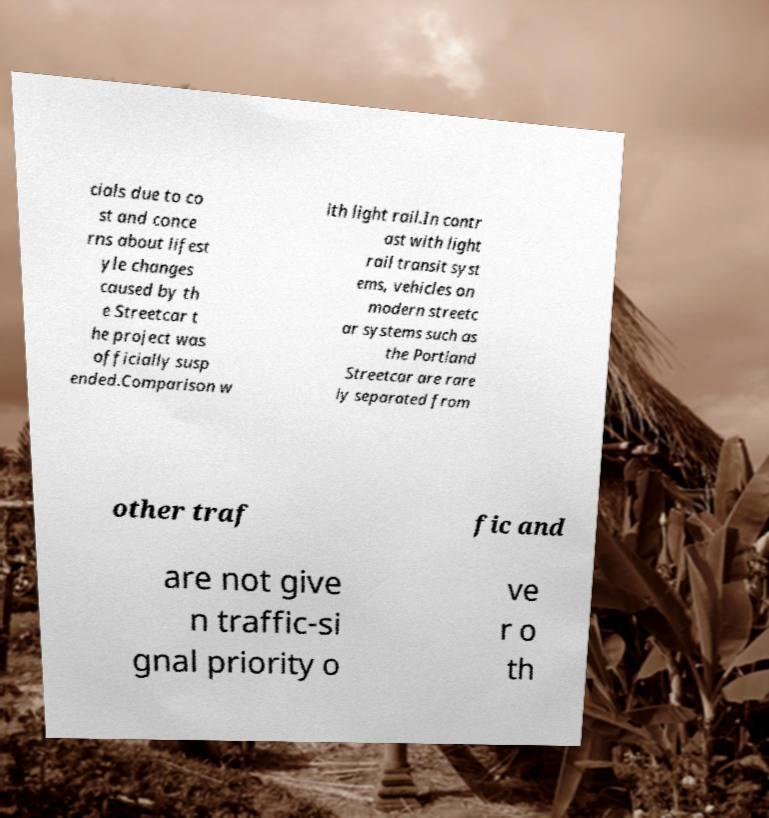Can you read and provide the text displayed in the image?This photo seems to have some interesting text. Can you extract and type it out for me? cials due to co st and conce rns about lifest yle changes caused by th e Streetcar t he project was officially susp ended.Comparison w ith light rail.In contr ast with light rail transit syst ems, vehicles on modern streetc ar systems such as the Portland Streetcar are rare ly separated from other traf fic and are not give n traffic-si gnal priority o ve r o th 